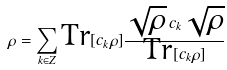Convert formula to latex. <formula><loc_0><loc_0><loc_500><loc_500>\rho = \sum _ { k \in Z } \text {Tr} [ c _ { k } \rho ] \frac { \sqrt { \rho } \, c _ { k } \sqrt { \rho } } { \text {Tr} [ c _ { k } \rho ] }</formula> 